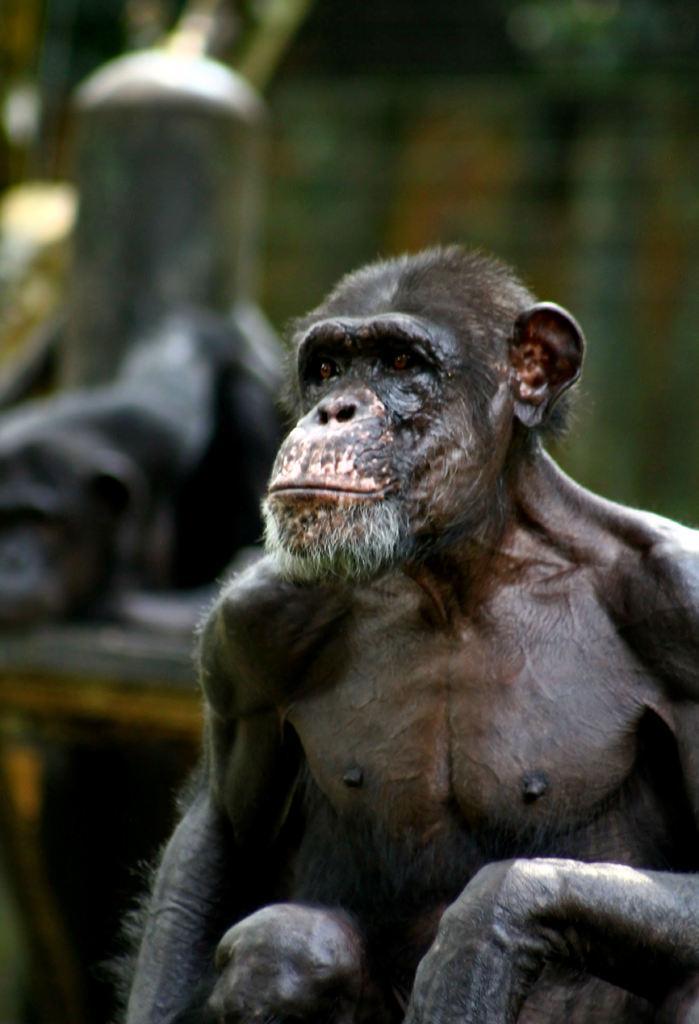Please provide a concise description of this image. In the picture there is a monkey present. 